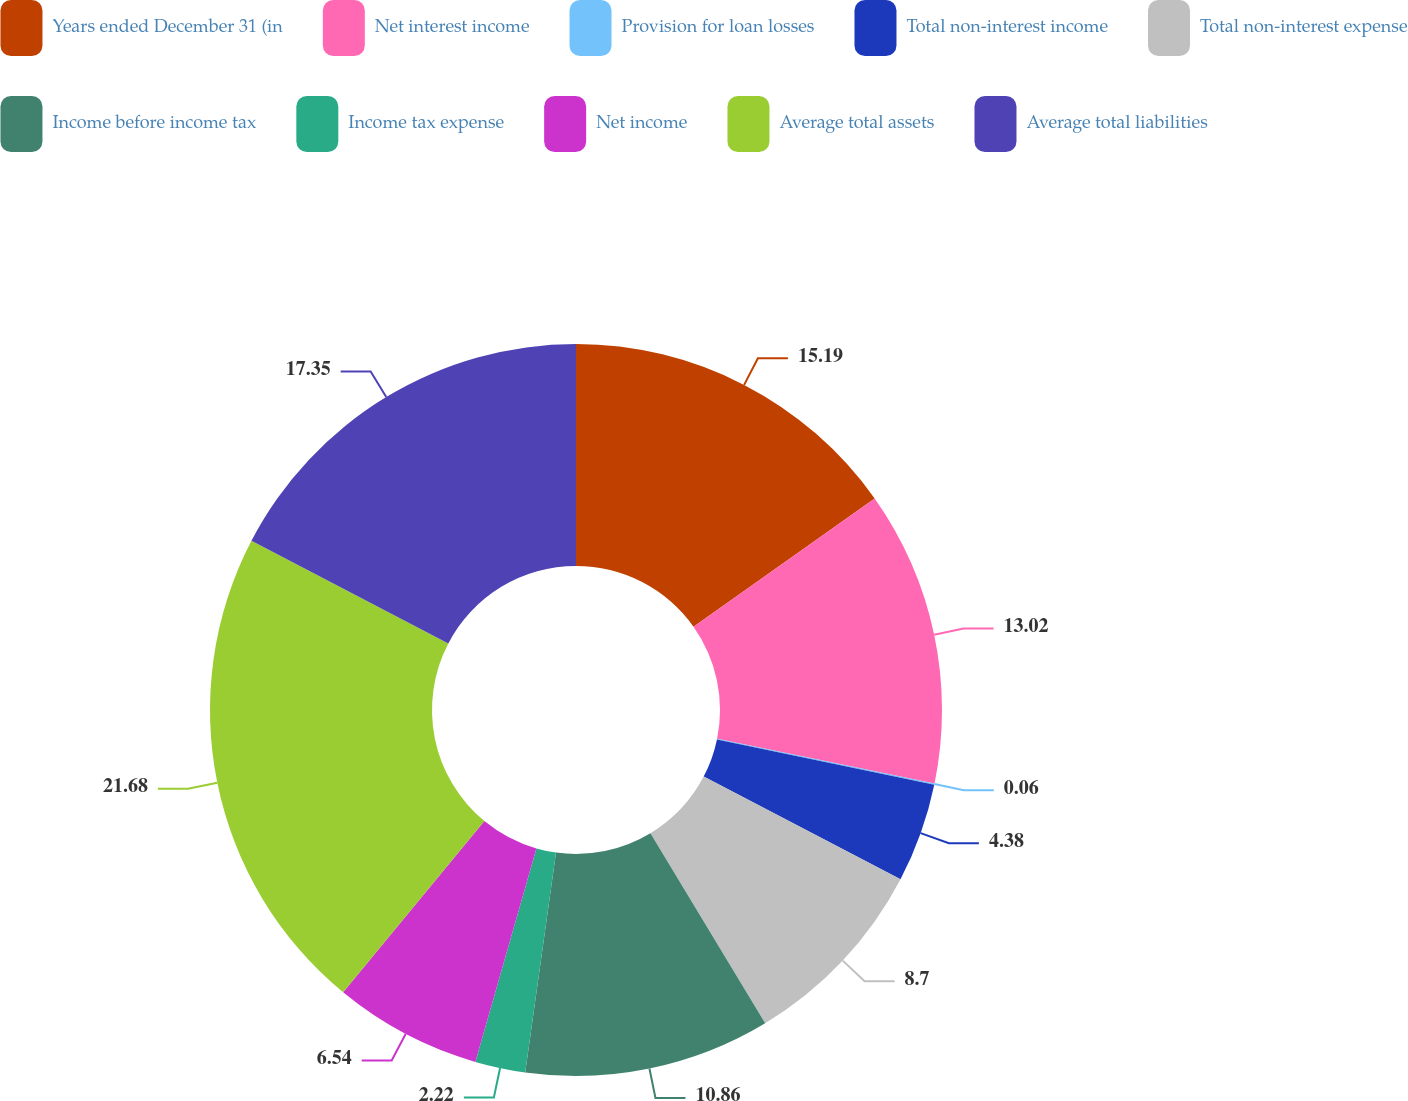<chart> <loc_0><loc_0><loc_500><loc_500><pie_chart><fcel>Years ended December 31 (in<fcel>Net interest income<fcel>Provision for loan losses<fcel>Total non-interest income<fcel>Total non-interest expense<fcel>Income before income tax<fcel>Income tax expense<fcel>Net income<fcel>Average total assets<fcel>Average total liabilities<nl><fcel>15.19%<fcel>13.02%<fcel>0.06%<fcel>4.38%<fcel>8.7%<fcel>10.86%<fcel>2.22%<fcel>6.54%<fcel>21.67%<fcel>17.35%<nl></chart> 